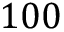<formula> <loc_0><loc_0><loc_500><loc_500>1 0 0</formula> 